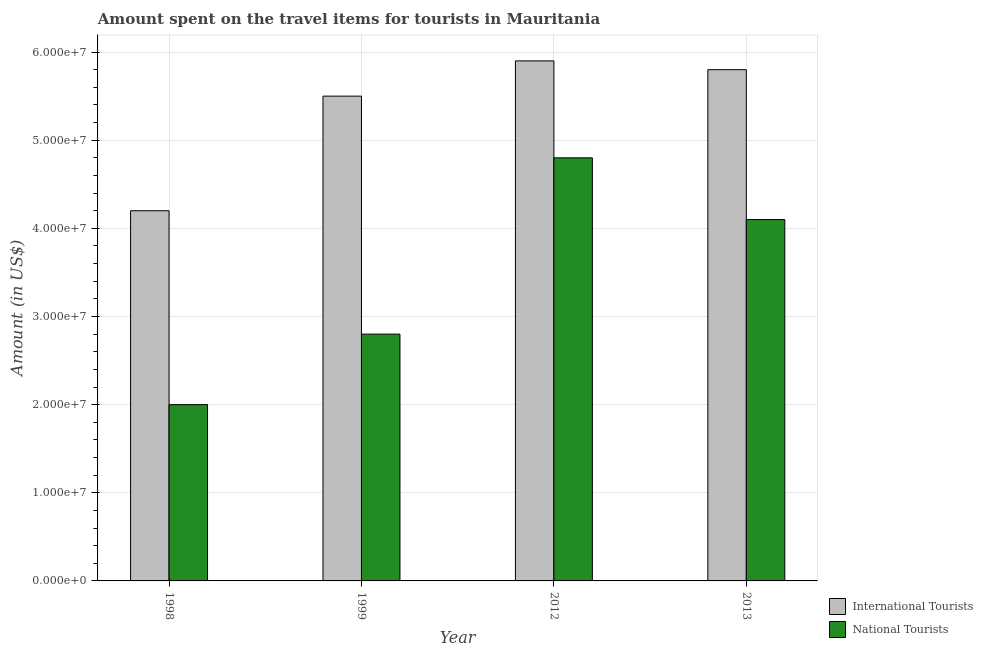Are the number of bars per tick equal to the number of legend labels?
Keep it short and to the point. Yes. Are the number of bars on each tick of the X-axis equal?
Offer a terse response. Yes. How many bars are there on the 1st tick from the left?
Offer a very short reply. 2. What is the label of the 2nd group of bars from the left?
Ensure brevity in your answer.  1999. In how many cases, is the number of bars for a given year not equal to the number of legend labels?
Your answer should be very brief. 0. What is the amount spent on travel items of international tourists in 1998?
Ensure brevity in your answer.  4.20e+07. Across all years, what is the maximum amount spent on travel items of international tourists?
Offer a very short reply. 5.90e+07. Across all years, what is the minimum amount spent on travel items of national tourists?
Offer a very short reply. 2.00e+07. In which year was the amount spent on travel items of national tourists maximum?
Your answer should be compact. 2012. What is the total amount spent on travel items of international tourists in the graph?
Provide a short and direct response. 2.14e+08. What is the difference between the amount spent on travel items of international tourists in 1999 and that in 2012?
Your answer should be very brief. -4.00e+06. What is the difference between the amount spent on travel items of national tourists in 2012 and the amount spent on travel items of international tourists in 1999?
Ensure brevity in your answer.  2.00e+07. What is the average amount spent on travel items of international tourists per year?
Provide a short and direct response. 5.35e+07. In the year 1999, what is the difference between the amount spent on travel items of international tourists and amount spent on travel items of national tourists?
Offer a terse response. 0. In how many years, is the amount spent on travel items of international tourists greater than 14000000 US$?
Your answer should be compact. 4. What is the ratio of the amount spent on travel items of national tourists in 2012 to that in 2013?
Provide a short and direct response. 1.17. Is the amount spent on travel items of national tourists in 1999 less than that in 2013?
Provide a succinct answer. Yes. Is the difference between the amount spent on travel items of national tourists in 1998 and 2012 greater than the difference between the amount spent on travel items of international tourists in 1998 and 2012?
Offer a very short reply. No. What is the difference between the highest and the second highest amount spent on travel items of international tourists?
Make the answer very short. 1.00e+06. What is the difference between the highest and the lowest amount spent on travel items of international tourists?
Ensure brevity in your answer.  1.70e+07. In how many years, is the amount spent on travel items of international tourists greater than the average amount spent on travel items of international tourists taken over all years?
Your answer should be compact. 3. What does the 2nd bar from the left in 1998 represents?
Offer a terse response. National Tourists. What does the 2nd bar from the right in 1998 represents?
Your response must be concise. International Tourists. Are all the bars in the graph horizontal?
Your answer should be very brief. No. Are the values on the major ticks of Y-axis written in scientific E-notation?
Give a very brief answer. Yes. Does the graph contain any zero values?
Keep it short and to the point. No. Where does the legend appear in the graph?
Provide a short and direct response. Bottom right. How many legend labels are there?
Keep it short and to the point. 2. What is the title of the graph?
Provide a short and direct response. Amount spent on the travel items for tourists in Mauritania. What is the Amount (in US$) of International Tourists in 1998?
Your answer should be very brief. 4.20e+07. What is the Amount (in US$) in National Tourists in 1998?
Provide a short and direct response. 2.00e+07. What is the Amount (in US$) of International Tourists in 1999?
Make the answer very short. 5.50e+07. What is the Amount (in US$) of National Tourists in 1999?
Keep it short and to the point. 2.80e+07. What is the Amount (in US$) of International Tourists in 2012?
Provide a succinct answer. 5.90e+07. What is the Amount (in US$) of National Tourists in 2012?
Your answer should be very brief. 4.80e+07. What is the Amount (in US$) of International Tourists in 2013?
Keep it short and to the point. 5.80e+07. What is the Amount (in US$) of National Tourists in 2013?
Keep it short and to the point. 4.10e+07. Across all years, what is the maximum Amount (in US$) of International Tourists?
Make the answer very short. 5.90e+07. Across all years, what is the maximum Amount (in US$) in National Tourists?
Your answer should be very brief. 4.80e+07. Across all years, what is the minimum Amount (in US$) in International Tourists?
Keep it short and to the point. 4.20e+07. Across all years, what is the minimum Amount (in US$) in National Tourists?
Ensure brevity in your answer.  2.00e+07. What is the total Amount (in US$) of International Tourists in the graph?
Offer a terse response. 2.14e+08. What is the total Amount (in US$) in National Tourists in the graph?
Offer a terse response. 1.37e+08. What is the difference between the Amount (in US$) of International Tourists in 1998 and that in 1999?
Offer a terse response. -1.30e+07. What is the difference between the Amount (in US$) in National Tourists in 1998 and that in 1999?
Make the answer very short. -8.00e+06. What is the difference between the Amount (in US$) in International Tourists in 1998 and that in 2012?
Provide a succinct answer. -1.70e+07. What is the difference between the Amount (in US$) in National Tourists in 1998 and that in 2012?
Your response must be concise. -2.80e+07. What is the difference between the Amount (in US$) of International Tourists in 1998 and that in 2013?
Ensure brevity in your answer.  -1.60e+07. What is the difference between the Amount (in US$) in National Tourists in 1998 and that in 2013?
Make the answer very short. -2.10e+07. What is the difference between the Amount (in US$) in International Tourists in 1999 and that in 2012?
Your answer should be compact. -4.00e+06. What is the difference between the Amount (in US$) in National Tourists in 1999 and that in 2012?
Make the answer very short. -2.00e+07. What is the difference between the Amount (in US$) in International Tourists in 1999 and that in 2013?
Make the answer very short. -3.00e+06. What is the difference between the Amount (in US$) of National Tourists in 1999 and that in 2013?
Ensure brevity in your answer.  -1.30e+07. What is the difference between the Amount (in US$) of International Tourists in 2012 and that in 2013?
Make the answer very short. 1.00e+06. What is the difference between the Amount (in US$) of National Tourists in 2012 and that in 2013?
Offer a terse response. 7.00e+06. What is the difference between the Amount (in US$) in International Tourists in 1998 and the Amount (in US$) in National Tourists in 1999?
Offer a very short reply. 1.40e+07. What is the difference between the Amount (in US$) of International Tourists in 1998 and the Amount (in US$) of National Tourists in 2012?
Provide a succinct answer. -6.00e+06. What is the difference between the Amount (in US$) of International Tourists in 1999 and the Amount (in US$) of National Tourists in 2012?
Give a very brief answer. 7.00e+06. What is the difference between the Amount (in US$) in International Tourists in 1999 and the Amount (in US$) in National Tourists in 2013?
Provide a short and direct response. 1.40e+07. What is the difference between the Amount (in US$) in International Tourists in 2012 and the Amount (in US$) in National Tourists in 2013?
Keep it short and to the point. 1.80e+07. What is the average Amount (in US$) in International Tourists per year?
Ensure brevity in your answer.  5.35e+07. What is the average Amount (in US$) of National Tourists per year?
Your response must be concise. 3.42e+07. In the year 1998, what is the difference between the Amount (in US$) of International Tourists and Amount (in US$) of National Tourists?
Offer a very short reply. 2.20e+07. In the year 1999, what is the difference between the Amount (in US$) in International Tourists and Amount (in US$) in National Tourists?
Your answer should be compact. 2.70e+07. In the year 2012, what is the difference between the Amount (in US$) in International Tourists and Amount (in US$) in National Tourists?
Provide a succinct answer. 1.10e+07. In the year 2013, what is the difference between the Amount (in US$) in International Tourists and Amount (in US$) in National Tourists?
Offer a terse response. 1.70e+07. What is the ratio of the Amount (in US$) in International Tourists in 1998 to that in 1999?
Provide a short and direct response. 0.76. What is the ratio of the Amount (in US$) in National Tourists in 1998 to that in 1999?
Your answer should be compact. 0.71. What is the ratio of the Amount (in US$) of International Tourists in 1998 to that in 2012?
Your answer should be compact. 0.71. What is the ratio of the Amount (in US$) of National Tourists in 1998 to that in 2012?
Ensure brevity in your answer.  0.42. What is the ratio of the Amount (in US$) of International Tourists in 1998 to that in 2013?
Offer a terse response. 0.72. What is the ratio of the Amount (in US$) of National Tourists in 1998 to that in 2013?
Provide a short and direct response. 0.49. What is the ratio of the Amount (in US$) in International Tourists in 1999 to that in 2012?
Keep it short and to the point. 0.93. What is the ratio of the Amount (in US$) of National Tourists in 1999 to that in 2012?
Offer a very short reply. 0.58. What is the ratio of the Amount (in US$) of International Tourists in 1999 to that in 2013?
Offer a very short reply. 0.95. What is the ratio of the Amount (in US$) in National Tourists in 1999 to that in 2013?
Make the answer very short. 0.68. What is the ratio of the Amount (in US$) of International Tourists in 2012 to that in 2013?
Your response must be concise. 1.02. What is the ratio of the Amount (in US$) in National Tourists in 2012 to that in 2013?
Offer a terse response. 1.17. What is the difference between the highest and the second highest Amount (in US$) in International Tourists?
Keep it short and to the point. 1.00e+06. What is the difference between the highest and the second highest Amount (in US$) in National Tourists?
Provide a succinct answer. 7.00e+06. What is the difference between the highest and the lowest Amount (in US$) of International Tourists?
Your answer should be very brief. 1.70e+07. What is the difference between the highest and the lowest Amount (in US$) of National Tourists?
Give a very brief answer. 2.80e+07. 